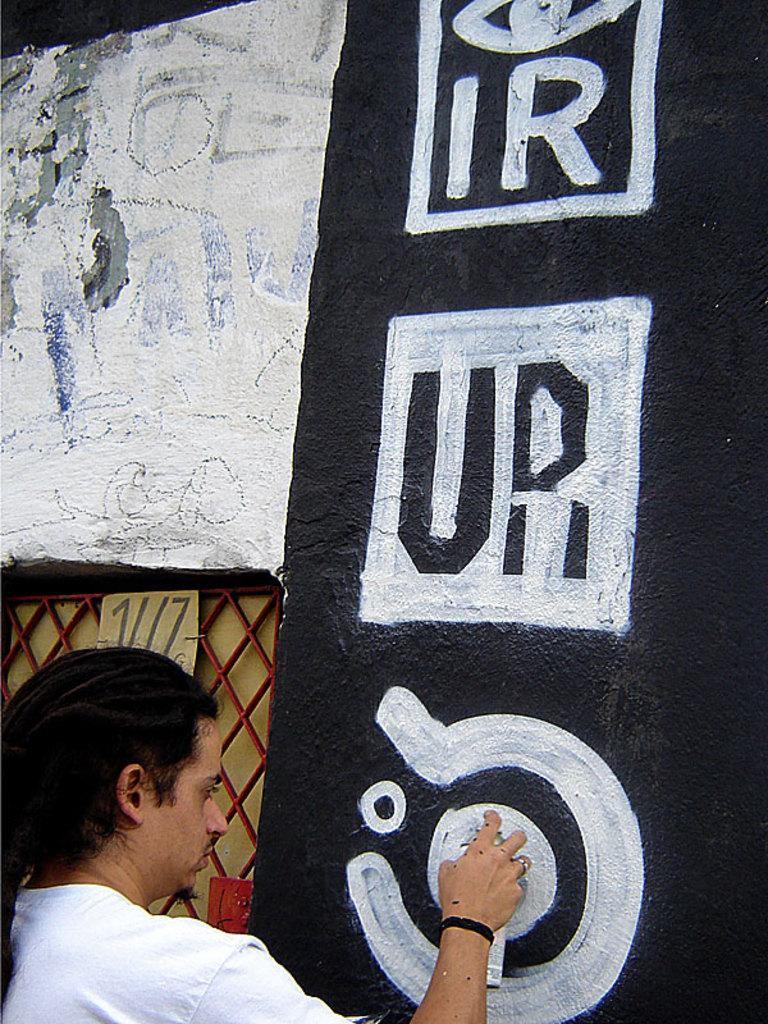What can be seen in the image? There is a person in the image. What is the person doing in the image? The person is holding an object. What is on the wall in the image? There is a painting on the wall in the image. Can you describe the board and mesh in the image? There is a board attached to a mesh in the image. What type of humor is being expressed by the person in the image? There is no indication of humor in the image; it simply shows a person holding an object. 